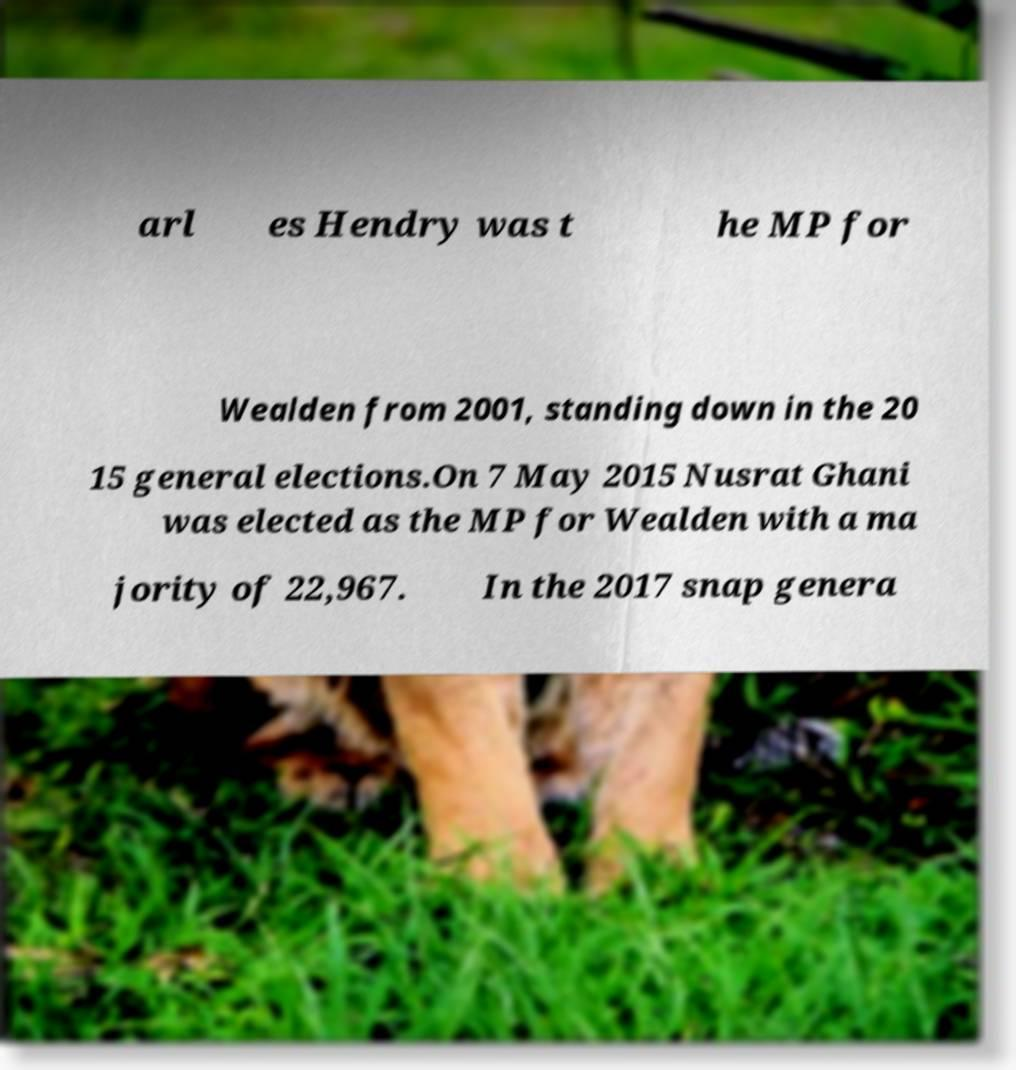Could you assist in decoding the text presented in this image and type it out clearly? arl es Hendry was t he MP for Wealden from 2001, standing down in the 20 15 general elections.On 7 May 2015 Nusrat Ghani was elected as the MP for Wealden with a ma jority of 22,967. In the 2017 snap genera 